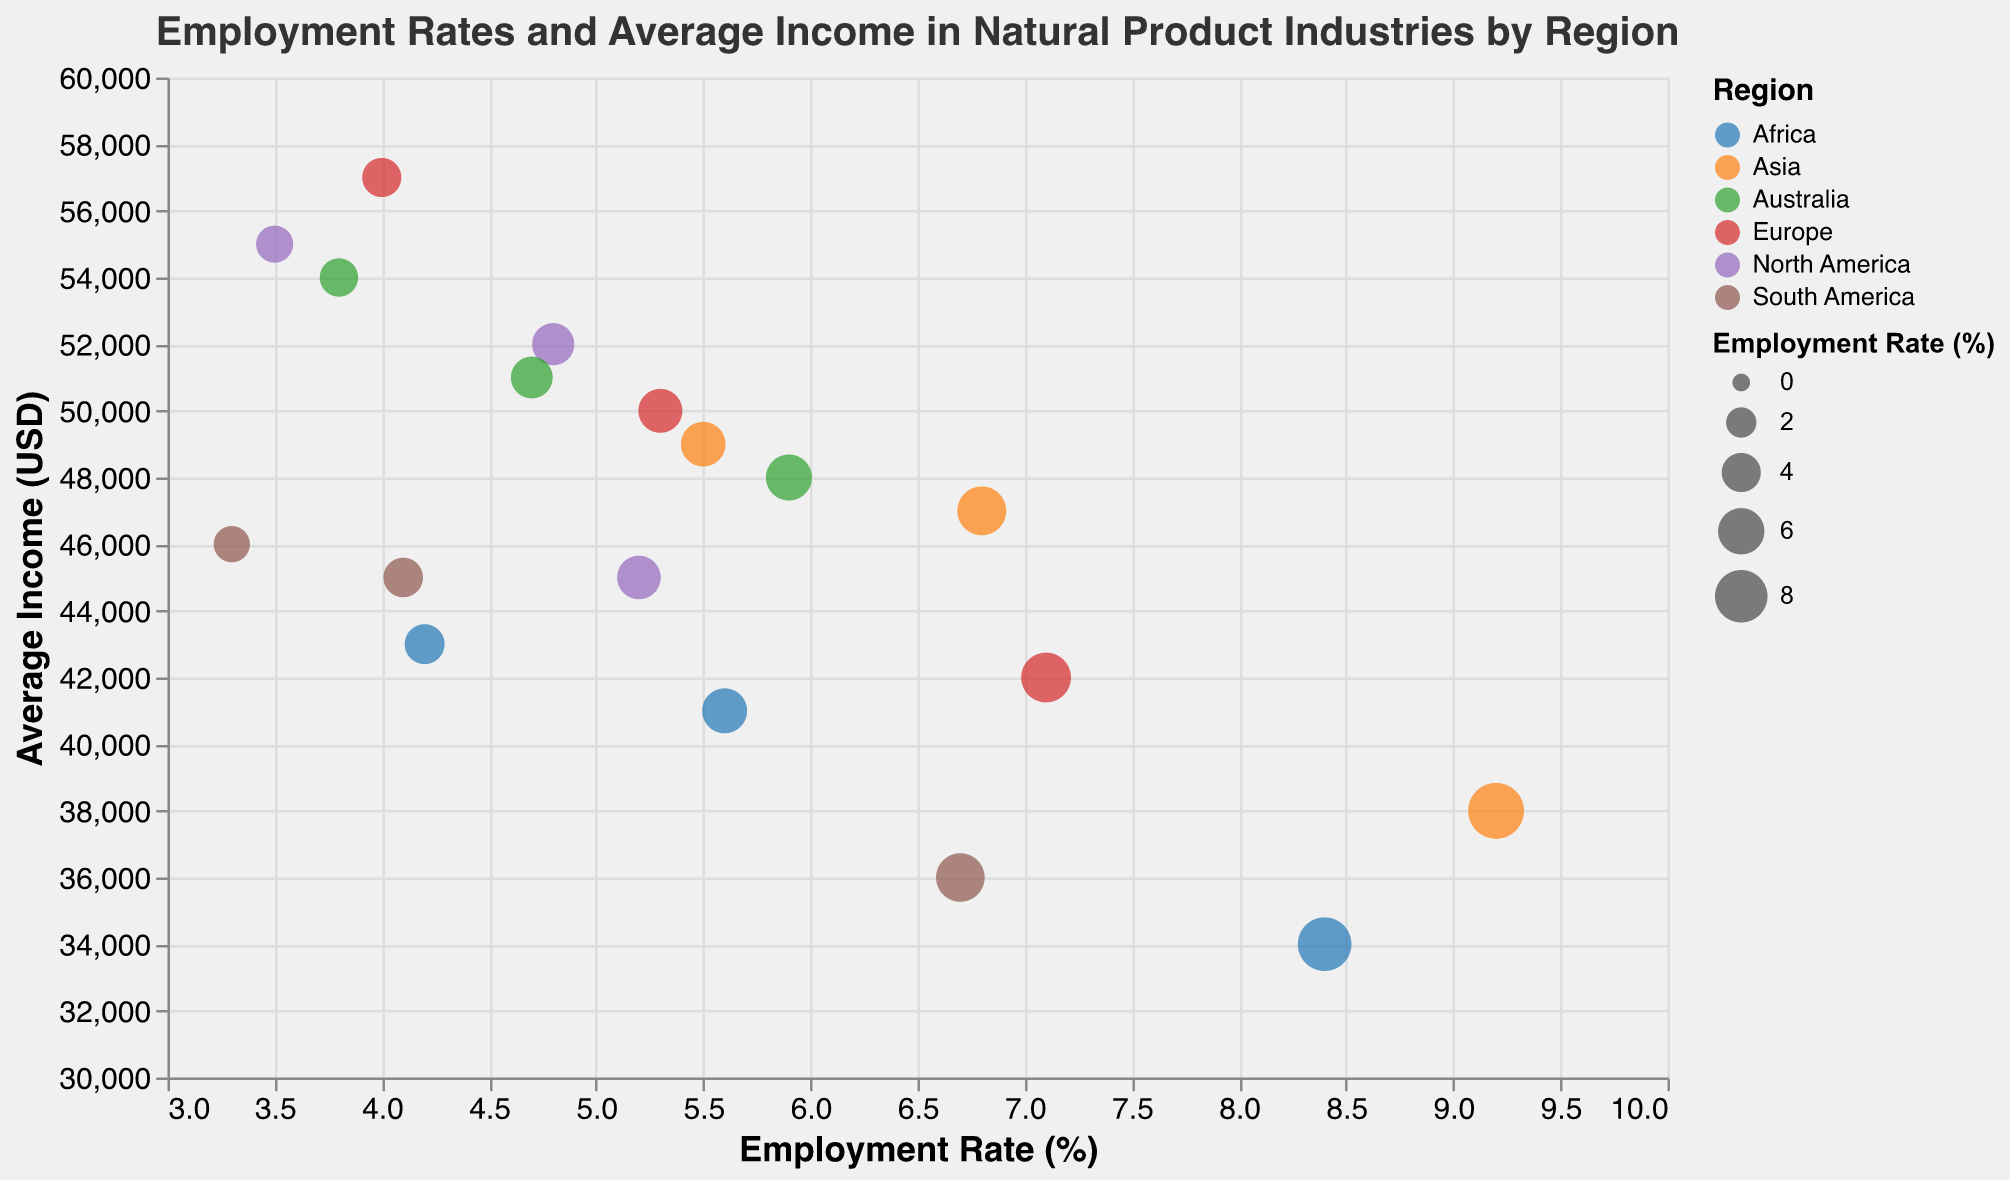What is the title of the bubble chart? The title of the bubble chart is usually displayed at the top of the chart. The title for this chart reads "Employment Rates and Average Income in Natural Product Industries by Region".
Answer: Employment Rates and Average Income in Natural Product Industries by Region What is the employment rate for Herbal Medicine in Europe? By looking at the bubble corresponding to Europe and Herbal Medicine, the employment rate is shown beside it. In this case, it is 4.0%.
Answer: 4.0% Which region has the highest employment rate for Organic Farming? Comparing all the bubbles labeled "Organic Farming" and observing their positions on the Employment Rate axis, it is evident that Asia has the highest employment rate for Organic Farming at 9.2%.
Answer: Asia Which industry in North America has the highest average income? By looking at the bubbles for North America and checking the y-axis positions (Average Income), the highest point corresponds to Herbal Medicine with an average income of $55,000.
Answer: Herbal Medicine How many industries are represented in the bubble chart? By observing the legend or the unique shapes of bubbles, it shows that there are three industries: Organic Farming, Herbal Medicine, and Natural Cosmetics.
Answer: Three What is the combined employment rate for Natural Cosmetics in Africa and Europe? Find the employment rate for Natural Cosmetics in Africa (5.6%) and Europe (5.3%) and sum them up: 5.6 + 5.3 = 10.9%.
Answer: 10.9% What is the difference in average income between Herbal Medicine and Organic Farming in North America? Check the average income for Herbal Medicine ($55,000) and Organic Farming ($45,000) in North America. Subtract the smaller from the larger: 55000 - 45000 = 10000.
Answer: 10,000 Which region appears to have the lowest average income in the Natural Cosmetics industry? By comparing the vertical positions (Average Income axis) of bubbles labeled as Natural Cosmetics across regions, Africa has the lowest average income at $41,000.
Answer: Africa What is the average employment rate for Herbal Medicine across all regions? Sum the employment rates for Herbal Medicine across all regions (3.5% + 4.0% + 5.5% + 3.3% + 4.2% + 3.8%) and divide by the number of regions (6): (3.5 + 4.0 + 5.5 + 3.3 + 4.2 + 3.8) / 6 ≈ 4.05%.
Answer: ~4.05% In which region does Natural Cosmetics have the highest employment rate? By comparing the employment rates of Natural Cosmetics in different regions, Asia has the highest employment rate at 6.8%.
Answer: Asia 